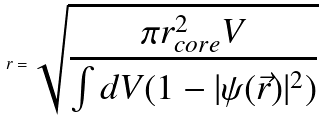<formula> <loc_0><loc_0><loc_500><loc_500>r = \sqrt { \frac { \pi r _ { c o r e } ^ { 2 } V } { \int d V ( 1 - | \psi ( \vec { r } ) | ^ { 2 } ) } }</formula> 